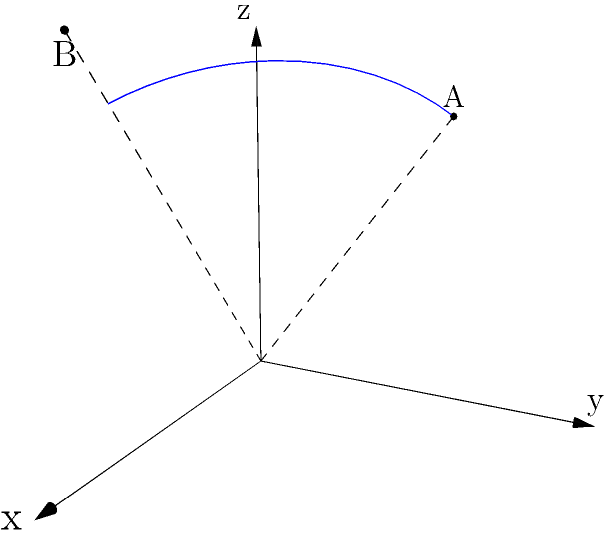Given two points in 3D space: $A(-1, 2, 3)$ and $B(2, -1, 4)$, expressed in Cartesian coordinates $(x, y, z)$. Convert these points to spherical coordinates $(r, \theta, \phi)$ and calculate the angular distance between them. Round your answer to the nearest hundredth of a radian. 1. Convert points A and B to spherical coordinates:

   For point A(-1, 2, 3):
   $r_A = \sqrt{(-1)^2 + 2^2 + 3^2} = \sqrt{14}$
   $\theta_A = \arccos(\frac{3}{\sqrt{14}}) \approx 0.7297$ radians
   $\phi_A = \arctan2(2, -1) + \pi \approx 2.0344$ radians

   For point B(2, -1, 4):
   $r_B = \sqrt{2^2 + (-1)^2 + 4^2} = \sqrt{21}$
   $\theta_B = \arccos(\frac{4}{\sqrt{21}}) \approx 0.6405$ radians
   $\phi_B = \arctan2(-1, 2) \approx -0.4636$ radians

2. Calculate the angular distance using the spherical law of cosines:

   $\Delta\sigma = \arccos(\sin\theta_A \sin\theta_B \cos(\phi_A - \phi_B) + \cos\theta_A \cos\theta_B)$

3. Substitute the values:

   $\Delta\sigma = \arccos(\sin(0.7297) \sin(0.6405) \cos(2.0344 - (-0.4636)) + \cos(0.7297) \cos(0.6405))$

4. Calculate:

   $\Delta\sigma \approx 1.2748$ radians

5. Round to the nearest hundredth:

   $\Delta\sigma \approx 1.27$ radians
Answer: $1.27$ radians 